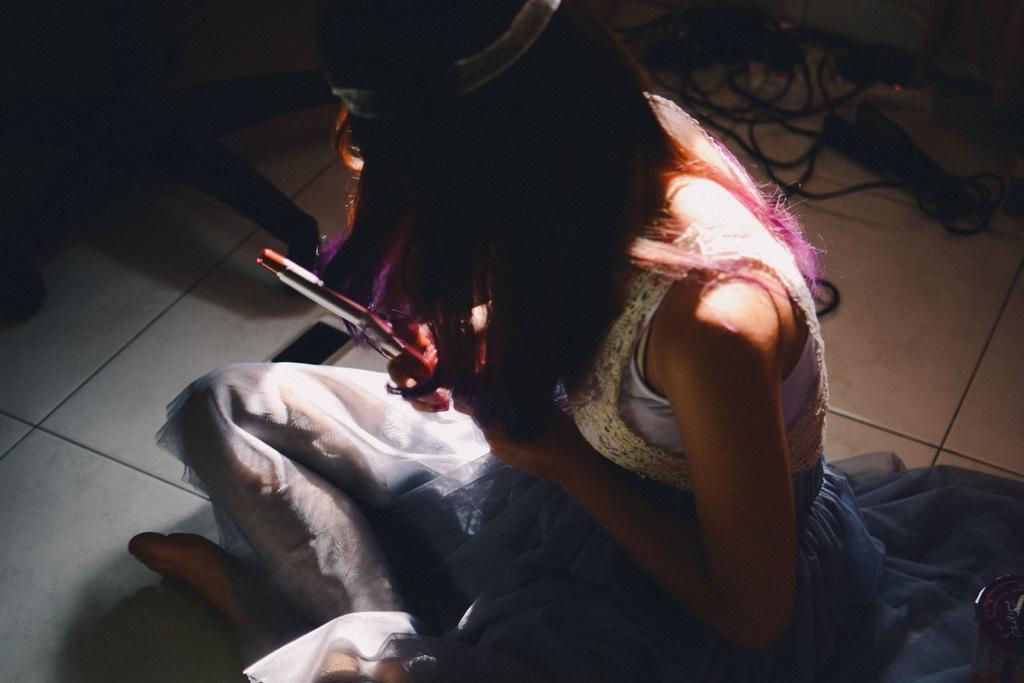How would you summarize this image in a sentence or two? This image is taken indoors. At the bottom of the image there is a floor. In the middle of the image a girl is sitting on the floor and she is holding a curl rod in her hand. 